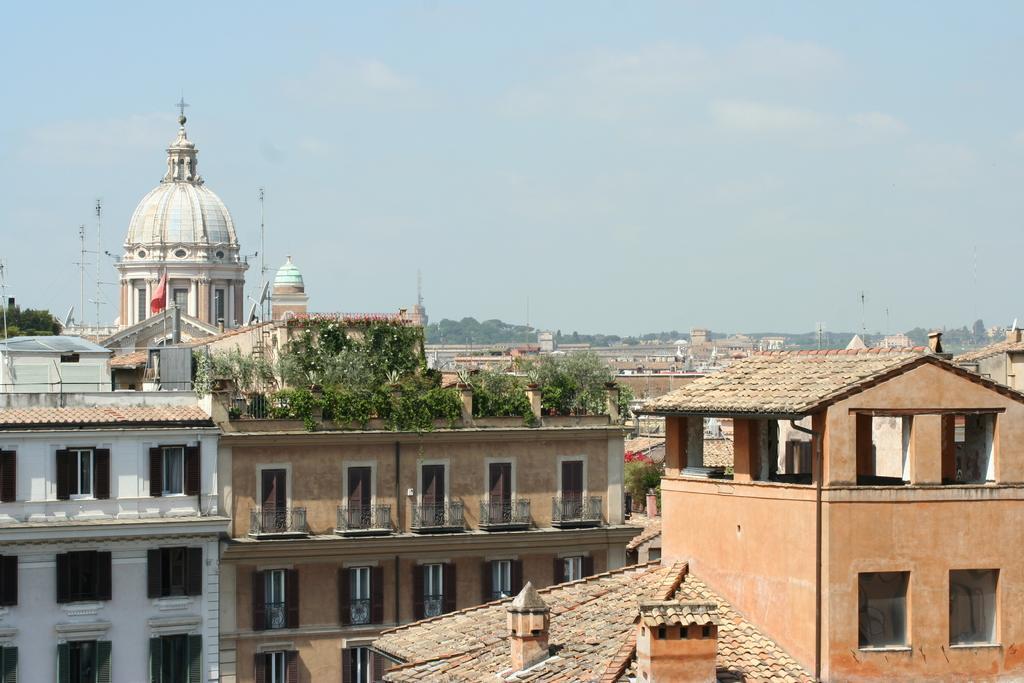Please provide a concise description of this image. To the bottom of the image there are many buildings with windows, walls, pillars and balcony. On the top of the building there are plants. And in the background there are trees and buildings. And also there are poles with wires. To the top of the image there is a sky. 